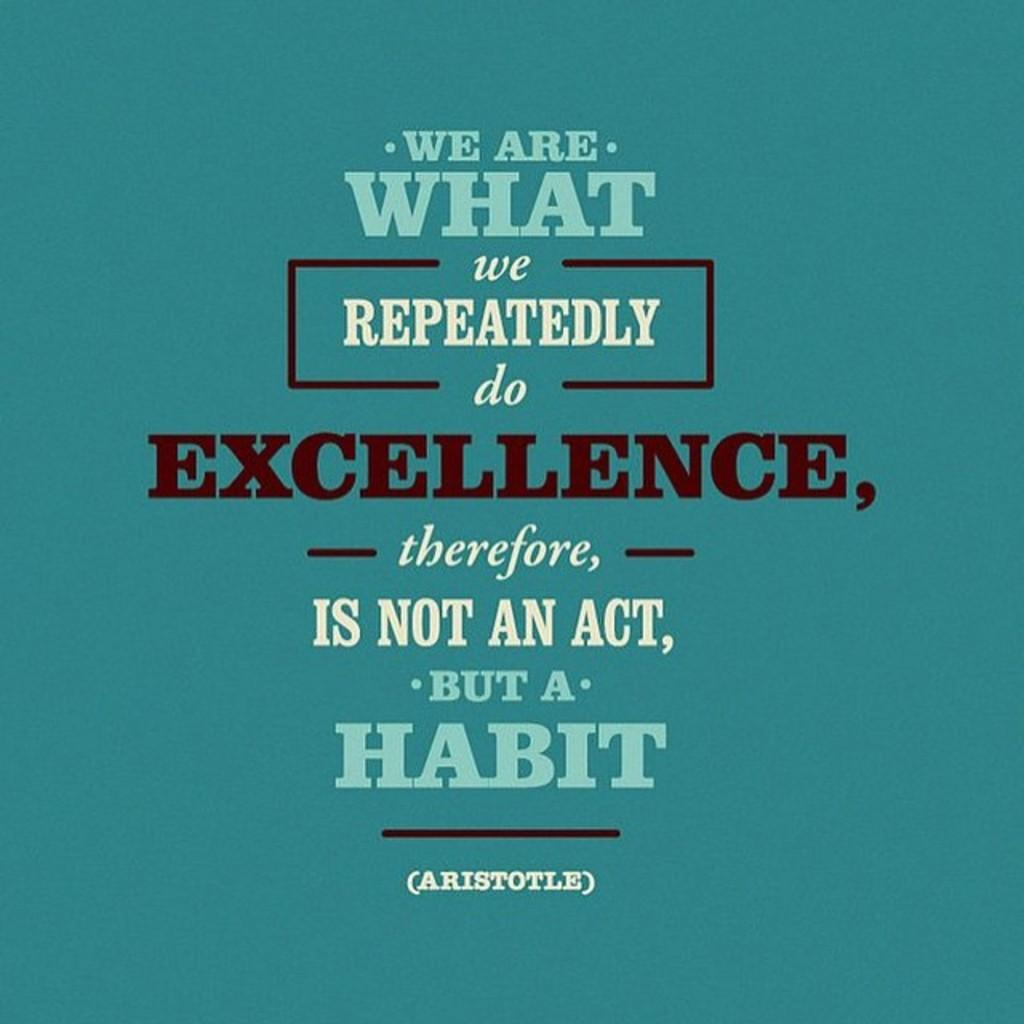<image>
Offer a succinct explanation of the picture presented. An Aristotle quote that is printed on a blue background. 